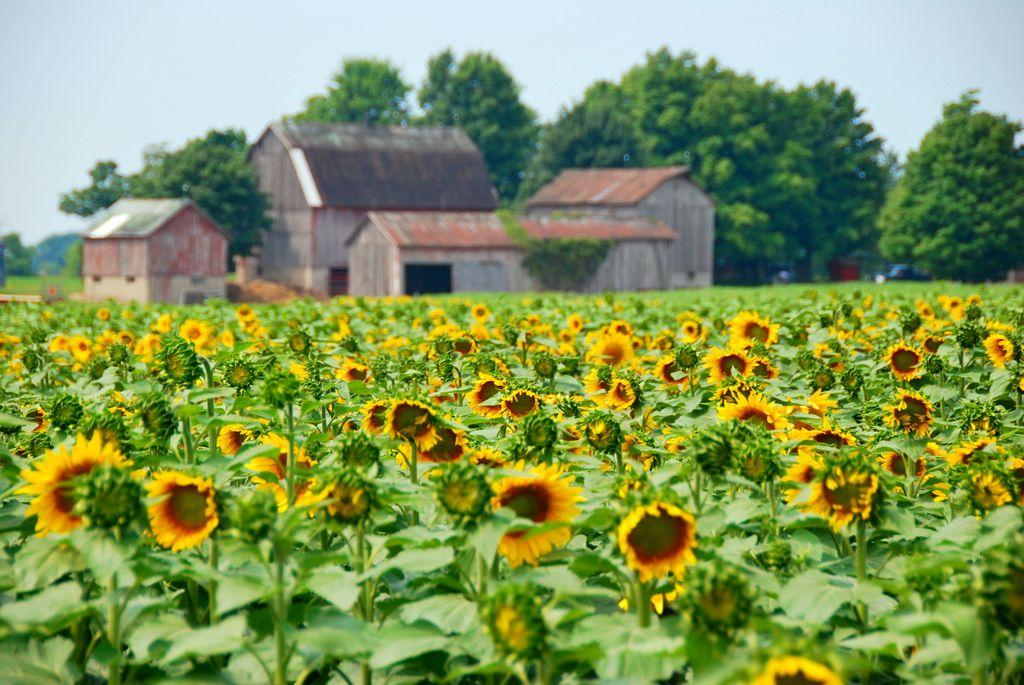What type of plants are in the front of the image? There are yellow sunflower plants in the front of the image. What is the color of the shade houses behind the sunflowers? The shade houses behind the sunflowers have a brown color. What can be seen in the background of the image? There are trees in the background of the image. What type of fuel is being used to power the sunflowers in the image? There is no fuel or power source mentioned or depicted in the image; the sunflowers are growing naturally. 